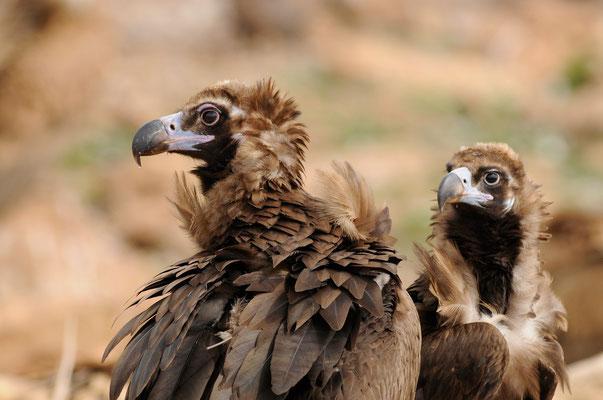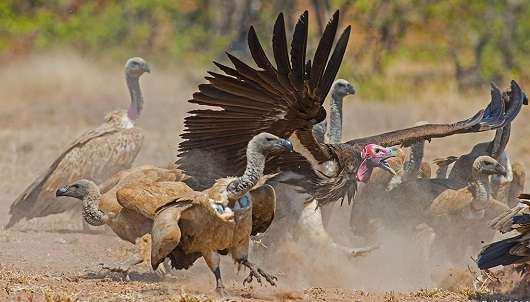The first image is the image on the left, the second image is the image on the right. Analyze the images presented: Is the assertion "A vulture has its wings spread, as it confronts another vulture" valid? Answer yes or no. Yes. The first image is the image on the left, the second image is the image on the right. For the images displayed, is the sentence "The left image shows one foreground vulture, which stands on a carcass with its head facing right." factually correct? Answer yes or no. No. 